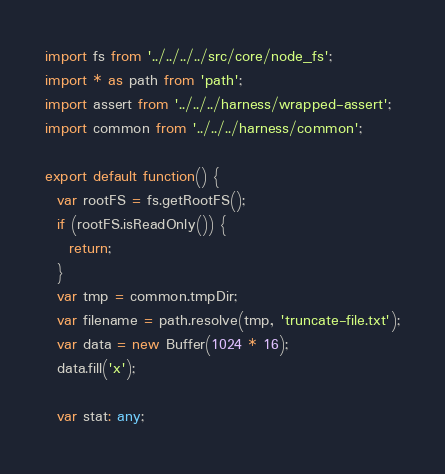<code> <loc_0><loc_0><loc_500><loc_500><_TypeScript_>import fs from '../../../../src/core/node_fs';
import * as path from 'path';
import assert from '../../../harness/wrapped-assert';
import common from '../../../harness/common';

export default function() {
  var rootFS = fs.getRootFS();
  if (rootFS.isReadOnly()) {
    return;
  }
  var tmp = common.tmpDir;
  var filename = path.resolve(tmp, 'truncate-file.txt');
  var data = new Buffer(1024 * 16);
  data.fill('x');

  var stat: any;
</code> 